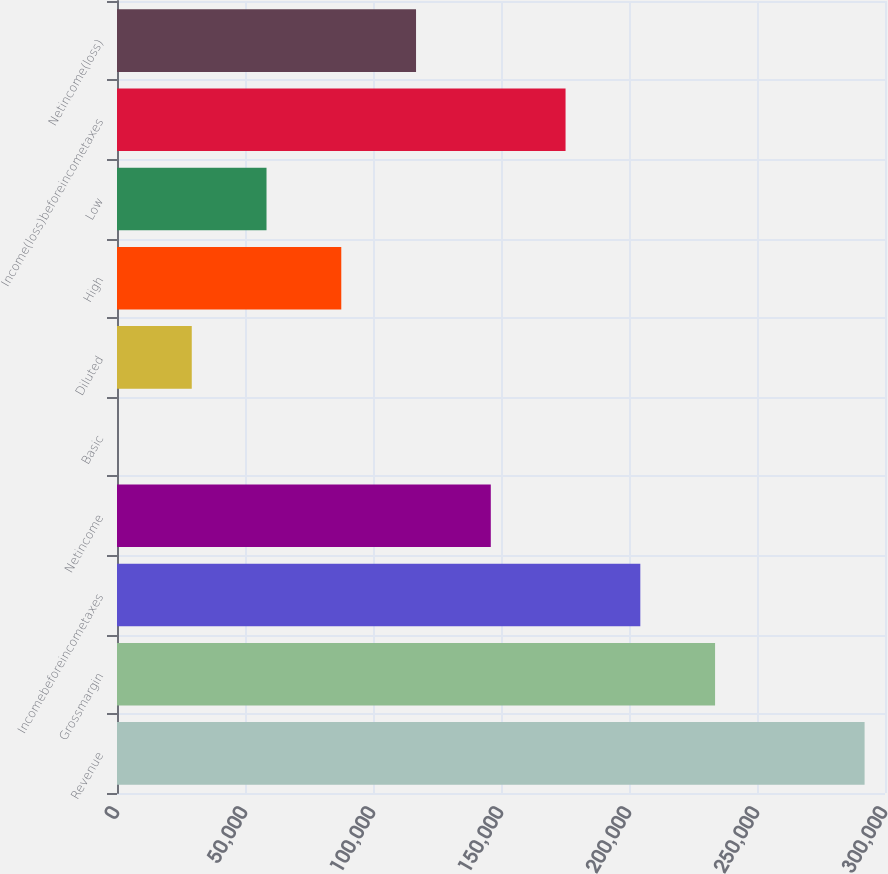Convert chart to OTSL. <chart><loc_0><loc_0><loc_500><loc_500><bar_chart><fcel>Revenue<fcel>Grossmargin<fcel>Incomebeforeincometaxes<fcel>Netincome<fcel>Basic<fcel>Diluted<fcel>High<fcel>Low<fcel>Income(loss)beforeincometaxes<fcel>Netincome(loss)<nl><fcel>292028<fcel>233622<fcel>204420<fcel>146014<fcel>0.15<fcel>29202.9<fcel>87608.5<fcel>58405.7<fcel>175217<fcel>116811<nl></chart> 